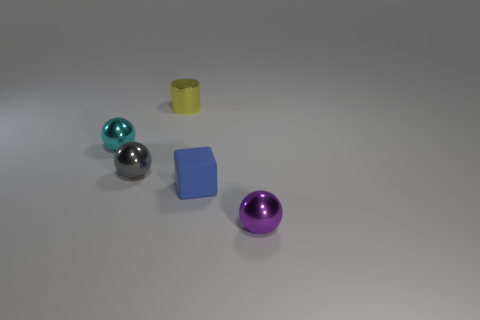Add 1 tiny blue cubes. How many objects exist? 6 Subtract all cylinders. How many objects are left? 4 Add 3 small blue blocks. How many small blue blocks are left? 4 Add 4 yellow metal objects. How many yellow metal objects exist? 5 Subtract 0 brown blocks. How many objects are left? 5 Subtract all tiny gray shiny spheres. Subtract all tiny metal spheres. How many objects are left? 1 